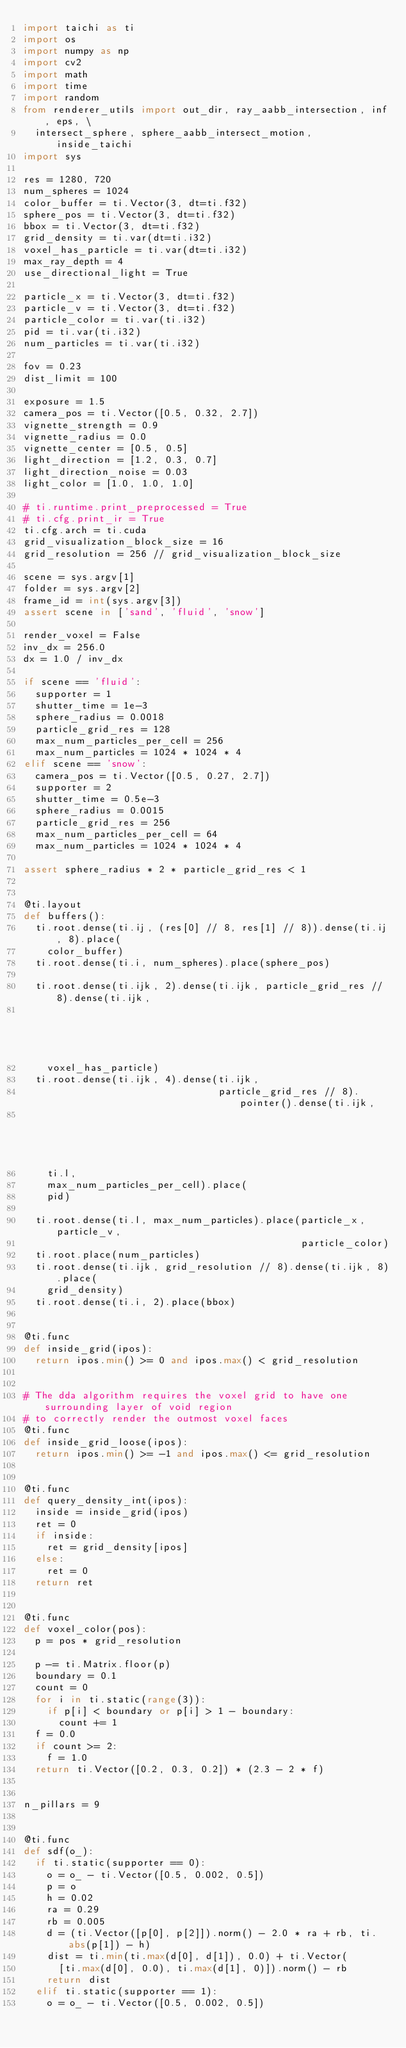Convert code to text. <code><loc_0><loc_0><loc_500><loc_500><_Python_>import taichi as ti
import os
import numpy as np
import cv2
import math
import time
import random
from renderer_utils import out_dir, ray_aabb_intersection, inf, eps, \
  intersect_sphere, sphere_aabb_intersect_motion, inside_taichi
import sys

res = 1280, 720
num_spheres = 1024
color_buffer = ti.Vector(3, dt=ti.f32)
sphere_pos = ti.Vector(3, dt=ti.f32)
bbox = ti.Vector(3, dt=ti.f32)
grid_density = ti.var(dt=ti.i32)
voxel_has_particle = ti.var(dt=ti.i32)
max_ray_depth = 4
use_directional_light = True

particle_x = ti.Vector(3, dt=ti.f32)
particle_v = ti.Vector(3, dt=ti.f32)
particle_color = ti.var(ti.i32)
pid = ti.var(ti.i32)
num_particles = ti.var(ti.i32)

fov = 0.23
dist_limit = 100

exposure = 1.5
camera_pos = ti.Vector([0.5, 0.32, 2.7])
vignette_strength = 0.9
vignette_radius = 0.0
vignette_center = [0.5, 0.5]
light_direction = [1.2, 0.3, 0.7]
light_direction_noise = 0.03
light_color = [1.0, 1.0, 1.0]

# ti.runtime.print_preprocessed = True
# ti.cfg.print_ir = True
ti.cfg.arch = ti.cuda
grid_visualization_block_size = 16
grid_resolution = 256 // grid_visualization_block_size

scene = sys.argv[1]
folder = sys.argv[2]
frame_id = int(sys.argv[3])
assert scene in ['sand', 'fluid', 'snow']

render_voxel = False
inv_dx = 256.0
dx = 1.0 / inv_dx

if scene == 'fluid':
  supporter = 1
  shutter_time = 1e-3
  sphere_radius = 0.0018
  particle_grid_res = 128
  max_num_particles_per_cell = 256
  max_num_particles = 1024 * 1024 * 4
elif scene == 'snow':
  camera_pos = ti.Vector([0.5, 0.27, 2.7])
  supporter = 2
  shutter_time = 0.5e-3
  sphere_radius = 0.0015
  particle_grid_res = 256
  max_num_particles_per_cell = 64
  max_num_particles = 1024 * 1024 * 4

assert sphere_radius * 2 * particle_grid_res < 1


@ti.layout
def buffers():
  ti.root.dense(ti.ij, (res[0] // 8, res[1] // 8)).dense(ti.ij, 8).place(
    color_buffer)
  ti.root.dense(ti.i, num_spheres).place(sphere_pos)
  
  ti.root.dense(ti.ijk, 2).dense(ti.ijk, particle_grid_res // 8).dense(ti.ijk,
                                                                       8).place(
    voxel_has_particle)
  ti.root.dense(ti.ijk, 4).dense(ti.ijk,
                                 particle_grid_res // 8).pointer().dense(ti.ijk,
                                                                         8).dynamic(
    ti.l,
    max_num_particles_per_cell).place(
    pid)
  
  ti.root.dense(ti.l, max_num_particles).place(particle_x, particle_v,
                                               particle_color)
  ti.root.place(num_particles)
  ti.root.dense(ti.ijk, grid_resolution // 8).dense(ti.ijk, 8).place(
    grid_density)
  ti.root.dense(ti.i, 2).place(bbox)


@ti.func
def inside_grid(ipos):
  return ipos.min() >= 0 and ipos.max() < grid_resolution


# The dda algorithm requires the voxel grid to have one surrounding layer of void region
# to correctly render the outmost voxel faces
@ti.func
def inside_grid_loose(ipos):
  return ipos.min() >= -1 and ipos.max() <= grid_resolution


@ti.func
def query_density_int(ipos):
  inside = inside_grid(ipos)
  ret = 0
  if inside:
    ret = grid_density[ipos]
  else:
    ret = 0
  return ret


@ti.func
def voxel_color(pos):
  p = pos * grid_resolution
  
  p -= ti.Matrix.floor(p)
  boundary = 0.1
  count = 0
  for i in ti.static(range(3)):
    if p[i] < boundary or p[i] > 1 - boundary:
      count += 1
  f = 0.0
  if count >= 2:
    f = 1.0
  return ti.Vector([0.2, 0.3, 0.2]) * (2.3 - 2 * f)


n_pillars = 9


@ti.func
def sdf(o_):
  if ti.static(supporter == 0):
    o = o_ - ti.Vector([0.5, 0.002, 0.5])
    p = o
    h = 0.02
    ra = 0.29
    rb = 0.005
    d = (ti.Vector([p[0], p[2]]).norm() - 2.0 * ra + rb, ti.abs(p[1]) - h)
    dist = ti.min(ti.max(d[0], d[1]), 0.0) + ti.Vector(
      [ti.max(d[0], 0.0), ti.max(d[1], 0)]).norm() - rb
    return dist
  elif ti.static(supporter == 1):
    o = o_ - ti.Vector([0.5, 0.002, 0.5])</code> 